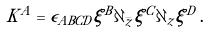Convert formula to latex. <formula><loc_0><loc_0><loc_500><loc_500>K ^ { A } = \epsilon _ { A B C D } \xi ^ { B } \partial _ { \bar { z } } \xi ^ { C } \partial _ { z } \xi ^ { D } \, .</formula> 